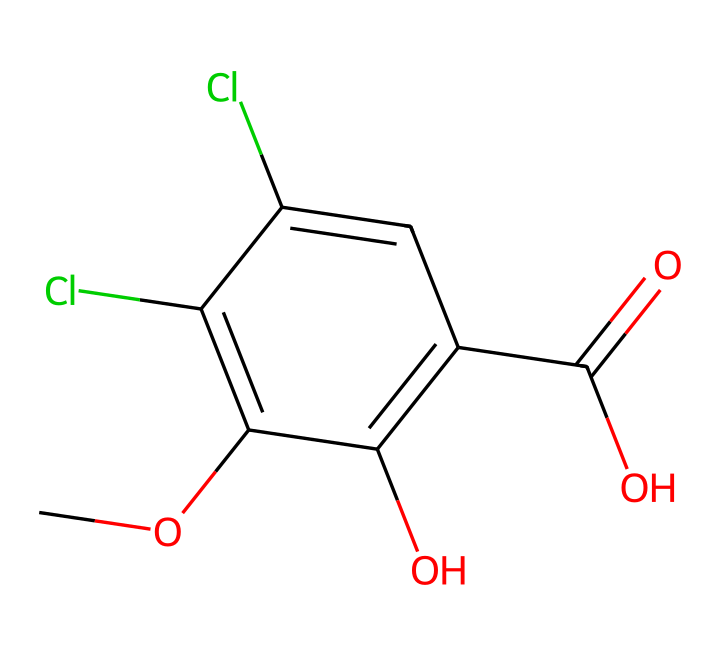What is the main functional group present in dicamba? The chemical structure contains a carboxylic acid group (-COOH) as indicated by the presence of a carbon atom double-bonded to an oxygen and bonded to a hydroxyl (-OH) group.
Answer: carboxylic acid How many chlorine atoms are in the molecular structure of dicamba? By analyzing the SMILES representation, there are two occurrences of 'Cl', which indicates the presence of two chlorine atoms in the structure.
Answer: two What is the significance of the methoxy group in dicamba? The methoxy group (-OCH3) is indicated by 'CO' at the beginning of the SMILES; it is significant as it can influence the herbicide's solubility and biological activity.
Answer: enhances solubility How does the arrangement of hydroxyl groups affect the herbicidal activity of dicamba? The two hydroxyl groups (-OH) are indicative of potential sites for hydrogen bonding, which could enhance the interaction of dicamba with target enzymes or proteins in plants, thus affecting its herbicidal action.
Answer: increases interaction What type of herbicide is dicamba classified as? Dicamba is widely recognized as a systemic herbicide, meaning it is absorbed through the foliage and translocated within the plant, distinguishing it in its mode of action.
Answer: systemic herbicide 